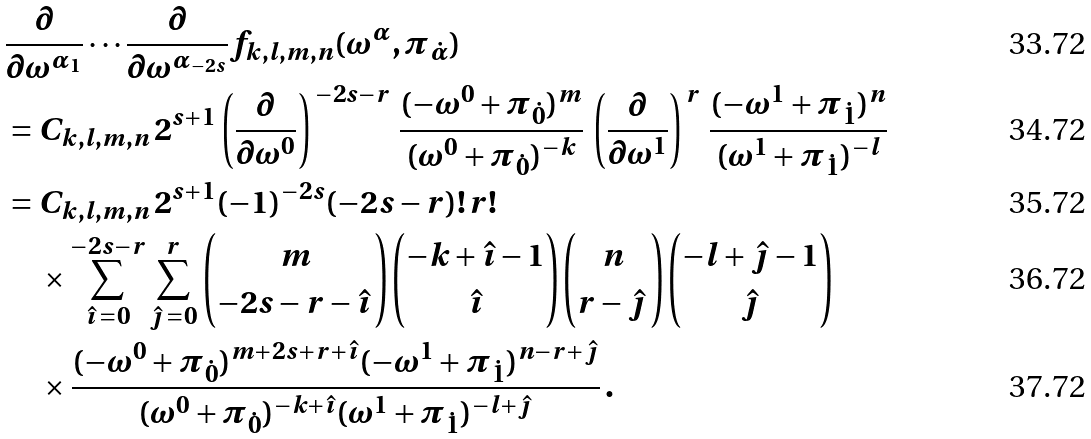<formula> <loc_0><loc_0><loc_500><loc_500>& \frac { \partial } { \partial \omega ^ { \alpha _ { 1 } } } \cdots \frac { \partial } { \partial \omega ^ { \alpha _ { - 2 s } } } f _ { k , l , m , n } ( \omega ^ { \alpha } , \pi _ { \dot { \alpha } } ) \\ & = C _ { k , l , m , n } \, 2 ^ { s + 1 } \left ( \frac { \partial } { \partial \omega ^ { 0 } } \right ) ^ { \, - 2 s - r } \, \frac { ( - \omega ^ { 0 } + \pi _ { \dot { 0 } } ) ^ { m } } { ( \omega ^ { 0 } + \pi _ { \dot { 0 } } ) ^ { - k } } \, \left ( \frac { \partial } { \partial \omega ^ { 1 } } \right ) ^ { \, r } \, \frac { ( - \omega ^ { 1 } + \pi _ { \dot { 1 } } ) ^ { n } } { ( \omega ^ { 1 } + \pi _ { \dot { 1 } } ) ^ { - l } } \\ & = C _ { k , l , m , n } \, 2 ^ { s + 1 } ( - 1 ) ^ { - 2 s } ( - 2 s - r ) ! \, r ! \\ & \quad \, \times \sum _ { \hat { \imath } \, = 0 } ^ { - 2 s - r } \sum _ { \hat { \jmath } \, = 0 } ^ { r } \binom { m } { - 2 s - r - \hat { \imath } \, } \binom { - k + \hat { \imath } - 1 } { \hat { \imath } } \binom { n } { r - \hat { \jmath } \, } \binom { - l + \hat { \jmath } - 1 } { \hat { \jmath } } \\ & \quad \, \times \frac { ( - \omega ^ { 0 } + \pi _ { \dot { 0 } } ) ^ { m + 2 s + r + \hat { \imath } } ( - \omega ^ { 1 } + \pi _ { \dot { 1 } } ) ^ { n - r + \hat { \jmath } } } { ( \omega ^ { 0 } + \pi _ { \dot { 0 } } ) ^ { - k + \hat { \imath } } ( \omega ^ { 1 } + \pi _ { \dot { 1 } } ) ^ { - l + \hat { \jmath } } } \, .</formula> 